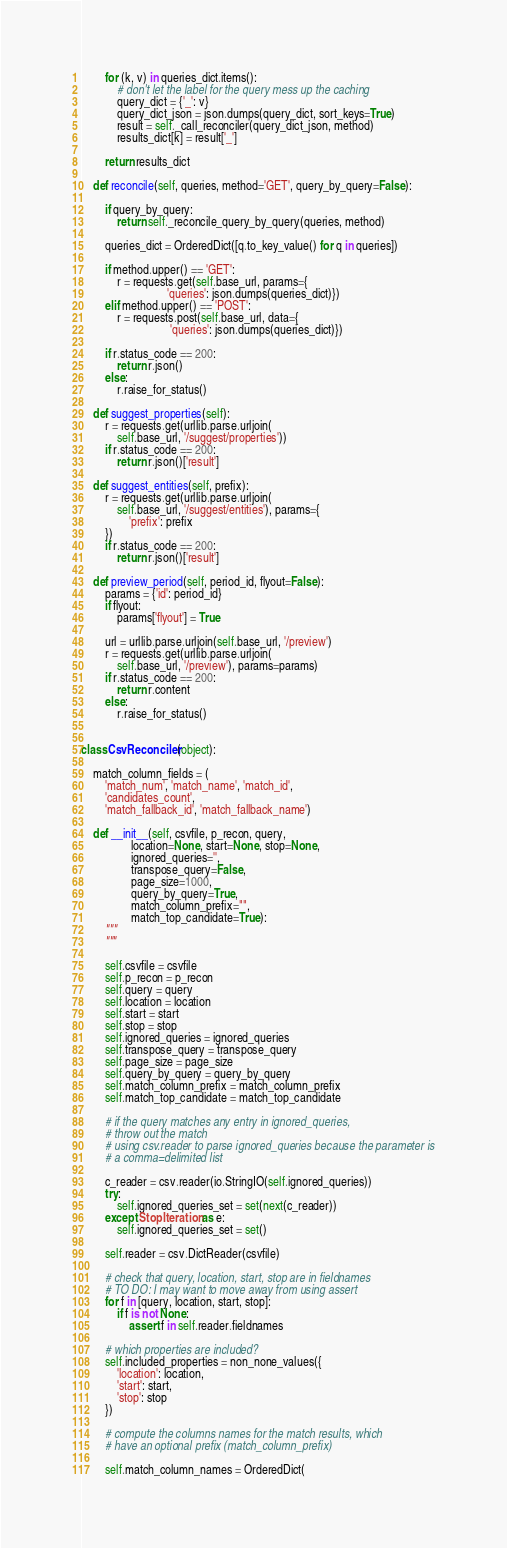<code> <loc_0><loc_0><loc_500><loc_500><_Python_>
        for (k, v) in queries_dict.items():
            # don't let the label for the query mess up the caching
            query_dict = {'_': v}
            query_dict_json = json.dumps(query_dict, sort_keys=True)
            result = self._call_reconciler(query_dict_json, method)
            results_dict[k] = result['_']

        return results_dict

    def reconcile(self, queries, method='GET', query_by_query=False):

        if query_by_query:
            return self._reconcile_query_by_query(queries, method)

        queries_dict = OrderedDict([q.to_key_value() for q in queries])

        if method.upper() == 'GET':
            r = requests.get(self.base_url, params={
                             'queries': json.dumps(queries_dict)})
        elif method.upper() == 'POST':
            r = requests.post(self.base_url, data={
                              'queries': json.dumps(queries_dict)})

        if r.status_code == 200:
            return r.json()
        else:
            r.raise_for_status()

    def suggest_properties(self):
        r = requests.get(urllib.parse.urljoin(
            self.base_url, '/suggest/properties'))
        if r.status_code == 200:
            return r.json()['result']

    def suggest_entities(self, prefix):
        r = requests.get(urllib.parse.urljoin(
            self.base_url, '/suggest/entities'), params={
                'prefix': prefix
        })
        if r.status_code == 200:
            return r.json()['result']

    def preview_period(self, period_id, flyout=False):
        params = {'id': period_id}
        if flyout:
            params['flyout'] = True

        url = urllib.parse.urljoin(self.base_url, '/preview')
        r = requests.get(urllib.parse.urljoin(
            self.base_url, '/preview'), params=params)
        if r.status_code == 200:
            return r.content
        else:
            r.raise_for_status()


class CsvReconciler(object):

    match_column_fields = (
        'match_num', 'match_name', 'match_id',
        'candidates_count',
        'match_fallback_id', 'match_fallback_name')

    def __init__(self, csvfile, p_recon, query,
                 location=None, start=None, stop=None,
                 ignored_queries='',
                 transpose_query=False,
                 page_size=1000,
                 query_by_query=True,
                 match_column_prefix="",
                 match_top_candidate=True):
        """
        """

        self.csvfile = csvfile
        self.p_recon = p_recon
        self.query = query
        self.location = location
        self.start = start
        self.stop = stop
        self.ignored_queries = ignored_queries
        self.transpose_query = transpose_query
        self.page_size = page_size
        self.query_by_query = query_by_query
        self.match_column_prefix = match_column_prefix
        self.match_top_candidate = match_top_candidate

        # if the query matches any entry in ignored_queries,
        # throw out the match
        # using csv.reader to parse ignored_queries because the parameter is
        # a comma=delimited list

        c_reader = csv.reader(io.StringIO(self.ignored_queries))
        try:
            self.ignored_queries_set = set(next(c_reader))
        except StopIteration as e:
            self.ignored_queries_set = set()

        self.reader = csv.DictReader(csvfile)

        # check that query, location, start, stop are in fieldnames
        # TO DO: I may want to move away from using assert
        for f in [query, location, start, stop]:
            if f is not None:
                assert f in self.reader.fieldnames

        # which properties are included?
        self.included_properties = non_none_values({
            'location': location,
            'start': start,
            'stop': stop
        })

        # compute the columns names for the match results, which
        # have an optional prefix (match_column_prefix)

        self.match_column_names = OrderedDict(</code> 